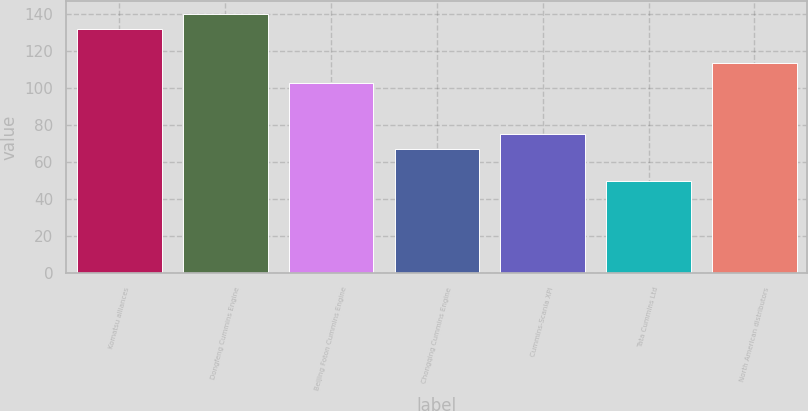Convert chart to OTSL. <chart><loc_0><loc_0><loc_500><loc_500><bar_chart><fcel>Komatsu alliances<fcel>Dongfeng Cummins Engine<fcel>Beijing Foton Cummins Engine<fcel>Chongqing Cummins Engine<fcel>Cummins-Scania XPI<fcel>Tata Cummins Ltd<fcel>North American distributors<nl><fcel>132<fcel>140.5<fcel>103<fcel>67<fcel>75.5<fcel>50<fcel>114<nl></chart> 